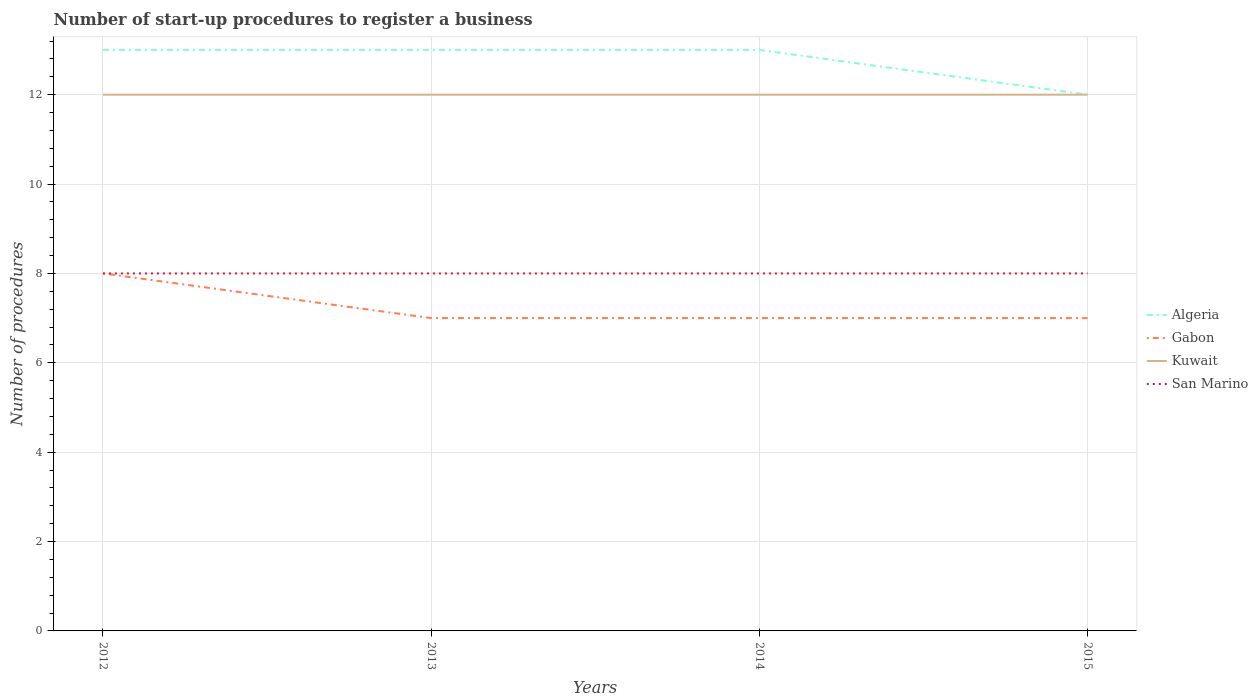Across all years, what is the maximum number of procedures required to register a business in San Marino?
Give a very brief answer. 8. What is the total number of procedures required to register a business in Kuwait in the graph?
Make the answer very short. 0. What is the difference between the highest and the second highest number of procedures required to register a business in San Marino?
Offer a very short reply. 0. What is the difference between the highest and the lowest number of procedures required to register a business in Kuwait?
Ensure brevity in your answer.  0. How many lines are there?
Give a very brief answer. 4. What is the difference between two consecutive major ticks on the Y-axis?
Provide a succinct answer. 2. Are the values on the major ticks of Y-axis written in scientific E-notation?
Make the answer very short. No. Does the graph contain grids?
Your response must be concise. Yes. Where does the legend appear in the graph?
Keep it short and to the point. Center right. What is the title of the graph?
Make the answer very short. Number of start-up procedures to register a business. What is the label or title of the Y-axis?
Provide a succinct answer. Number of procedures. What is the Number of procedures in Algeria in 2012?
Provide a short and direct response. 13. What is the Number of procedures in Gabon in 2012?
Offer a very short reply. 8. What is the Number of procedures of Gabon in 2013?
Your answer should be very brief. 7. What is the Number of procedures of Algeria in 2014?
Your response must be concise. 13. What is the Number of procedures in Algeria in 2015?
Provide a succinct answer. 12. What is the Number of procedures in Kuwait in 2015?
Give a very brief answer. 12. What is the Number of procedures in San Marino in 2015?
Make the answer very short. 8. Across all years, what is the maximum Number of procedures in Kuwait?
Offer a terse response. 12. Across all years, what is the maximum Number of procedures of San Marino?
Keep it short and to the point. 8. Across all years, what is the minimum Number of procedures in San Marino?
Give a very brief answer. 8. What is the total Number of procedures in Algeria in the graph?
Your response must be concise. 51. What is the total Number of procedures of Gabon in the graph?
Your response must be concise. 29. What is the difference between the Number of procedures of Algeria in 2012 and that in 2013?
Make the answer very short. 0. What is the difference between the Number of procedures of Gabon in 2012 and that in 2013?
Keep it short and to the point. 1. What is the difference between the Number of procedures of Kuwait in 2012 and that in 2013?
Offer a very short reply. 0. What is the difference between the Number of procedures of Gabon in 2012 and that in 2014?
Ensure brevity in your answer.  1. What is the difference between the Number of procedures of Kuwait in 2012 and that in 2014?
Your response must be concise. 0. What is the difference between the Number of procedures in San Marino in 2012 and that in 2014?
Keep it short and to the point. 0. What is the difference between the Number of procedures in Kuwait in 2012 and that in 2015?
Offer a very short reply. 0. What is the difference between the Number of procedures in San Marino in 2012 and that in 2015?
Ensure brevity in your answer.  0. What is the difference between the Number of procedures in Algeria in 2013 and that in 2014?
Offer a terse response. 0. What is the difference between the Number of procedures in Gabon in 2013 and that in 2014?
Keep it short and to the point. 0. What is the difference between the Number of procedures in San Marino in 2013 and that in 2014?
Your answer should be compact. 0. What is the difference between the Number of procedures in Kuwait in 2013 and that in 2015?
Your answer should be compact. 0. What is the difference between the Number of procedures in Algeria in 2014 and that in 2015?
Your answer should be very brief. 1. What is the difference between the Number of procedures of San Marino in 2014 and that in 2015?
Offer a terse response. 0. What is the difference between the Number of procedures of Algeria in 2012 and the Number of procedures of Kuwait in 2013?
Keep it short and to the point. 1. What is the difference between the Number of procedures in Algeria in 2012 and the Number of procedures in San Marino in 2013?
Your answer should be very brief. 5. What is the difference between the Number of procedures in Algeria in 2012 and the Number of procedures in Kuwait in 2014?
Your response must be concise. 1. What is the difference between the Number of procedures of Algeria in 2012 and the Number of procedures of San Marino in 2014?
Your response must be concise. 5. What is the difference between the Number of procedures in Gabon in 2012 and the Number of procedures in Kuwait in 2014?
Your answer should be very brief. -4. What is the difference between the Number of procedures of Kuwait in 2012 and the Number of procedures of San Marino in 2014?
Keep it short and to the point. 4. What is the difference between the Number of procedures in Algeria in 2012 and the Number of procedures in Gabon in 2015?
Offer a very short reply. 6. What is the difference between the Number of procedures in Algeria in 2012 and the Number of procedures in Kuwait in 2015?
Give a very brief answer. 1. What is the difference between the Number of procedures in Gabon in 2012 and the Number of procedures in Kuwait in 2015?
Ensure brevity in your answer.  -4. What is the difference between the Number of procedures in Algeria in 2013 and the Number of procedures in Gabon in 2014?
Keep it short and to the point. 6. What is the difference between the Number of procedures of Algeria in 2013 and the Number of procedures of Kuwait in 2014?
Give a very brief answer. 1. What is the difference between the Number of procedures in Algeria in 2013 and the Number of procedures in San Marino in 2014?
Keep it short and to the point. 5. What is the difference between the Number of procedures of Gabon in 2013 and the Number of procedures of San Marino in 2014?
Offer a terse response. -1. What is the difference between the Number of procedures of Kuwait in 2013 and the Number of procedures of San Marino in 2014?
Keep it short and to the point. 4. What is the difference between the Number of procedures in Algeria in 2013 and the Number of procedures in Kuwait in 2015?
Offer a terse response. 1. What is the difference between the Number of procedures of Gabon in 2013 and the Number of procedures of Kuwait in 2015?
Your response must be concise. -5. What is the difference between the Number of procedures of Kuwait in 2013 and the Number of procedures of San Marino in 2015?
Keep it short and to the point. 4. What is the difference between the Number of procedures of Algeria in 2014 and the Number of procedures of San Marino in 2015?
Your response must be concise. 5. What is the difference between the Number of procedures of Gabon in 2014 and the Number of procedures of Kuwait in 2015?
Ensure brevity in your answer.  -5. What is the difference between the Number of procedures of Kuwait in 2014 and the Number of procedures of San Marino in 2015?
Offer a very short reply. 4. What is the average Number of procedures of Algeria per year?
Your answer should be very brief. 12.75. What is the average Number of procedures in Gabon per year?
Offer a very short reply. 7.25. In the year 2012, what is the difference between the Number of procedures of Algeria and Number of procedures of Gabon?
Keep it short and to the point. 5. In the year 2013, what is the difference between the Number of procedures of Algeria and Number of procedures of Gabon?
Provide a succinct answer. 6. In the year 2013, what is the difference between the Number of procedures of Algeria and Number of procedures of Kuwait?
Give a very brief answer. 1. In the year 2013, what is the difference between the Number of procedures in Gabon and Number of procedures in San Marino?
Offer a very short reply. -1. In the year 2014, what is the difference between the Number of procedures in Algeria and Number of procedures in Gabon?
Give a very brief answer. 6. In the year 2014, what is the difference between the Number of procedures of Algeria and Number of procedures of Kuwait?
Your answer should be compact. 1. In the year 2014, what is the difference between the Number of procedures of Gabon and Number of procedures of San Marino?
Ensure brevity in your answer.  -1. In the year 2015, what is the difference between the Number of procedures in Algeria and Number of procedures in Gabon?
Provide a succinct answer. 5. In the year 2015, what is the difference between the Number of procedures of Algeria and Number of procedures of Kuwait?
Provide a succinct answer. 0. In the year 2015, what is the difference between the Number of procedures in Algeria and Number of procedures in San Marino?
Ensure brevity in your answer.  4. In the year 2015, what is the difference between the Number of procedures of Gabon and Number of procedures of Kuwait?
Make the answer very short. -5. In the year 2015, what is the difference between the Number of procedures of Gabon and Number of procedures of San Marino?
Give a very brief answer. -1. In the year 2015, what is the difference between the Number of procedures of Kuwait and Number of procedures of San Marino?
Provide a succinct answer. 4. What is the ratio of the Number of procedures of Algeria in 2012 to that in 2013?
Provide a succinct answer. 1. What is the ratio of the Number of procedures of Algeria in 2012 to that in 2014?
Your response must be concise. 1. What is the ratio of the Number of procedures of Gabon in 2012 to that in 2014?
Offer a very short reply. 1.14. What is the ratio of the Number of procedures in San Marino in 2012 to that in 2015?
Ensure brevity in your answer.  1. What is the ratio of the Number of procedures of Algeria in 2013 to that in 2014?
Provide a short and direct response. 1. What is the ratio of the Number of procedures in Gabon in 2013 to that in 2014?
Your answer should be very brief. 1. What is the ratio of the Number of procedures of Kuwait in 2013 to that in 2014?
Ensure brevity in your answer.  1. What is the ratio of the Number of procedures of San Marino in 2013 to that in 2014?
Offer a terse response. 1. What is the ratio of the Number of procedures in San Marino in 2013 to that in 2015?
Offer a very short reply. 1. What is the difference between the highest and the second highest Number of procedures of Kuwait?
Offer a terse response. 0. What is the difference between the highest and the second highest Number of procedures of San Marino?
Make the answer very short. 0. What is the difference between the highest and the lowest Number of procedures in San Marino?
Make the answer very short. 0. 